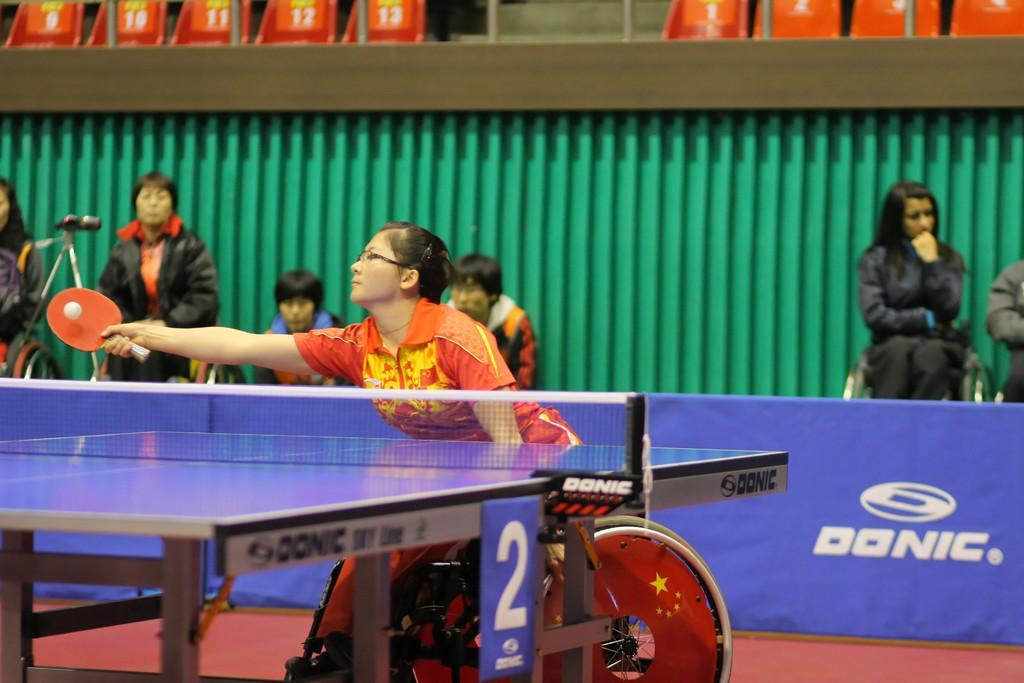In one or two sentences, can you explain what this image depicts? Behind to the hoarding we can see few persons sitting and standing. At the top we can see empty chairs. Here we can see a women on a wheelchair playing a table tennis. 